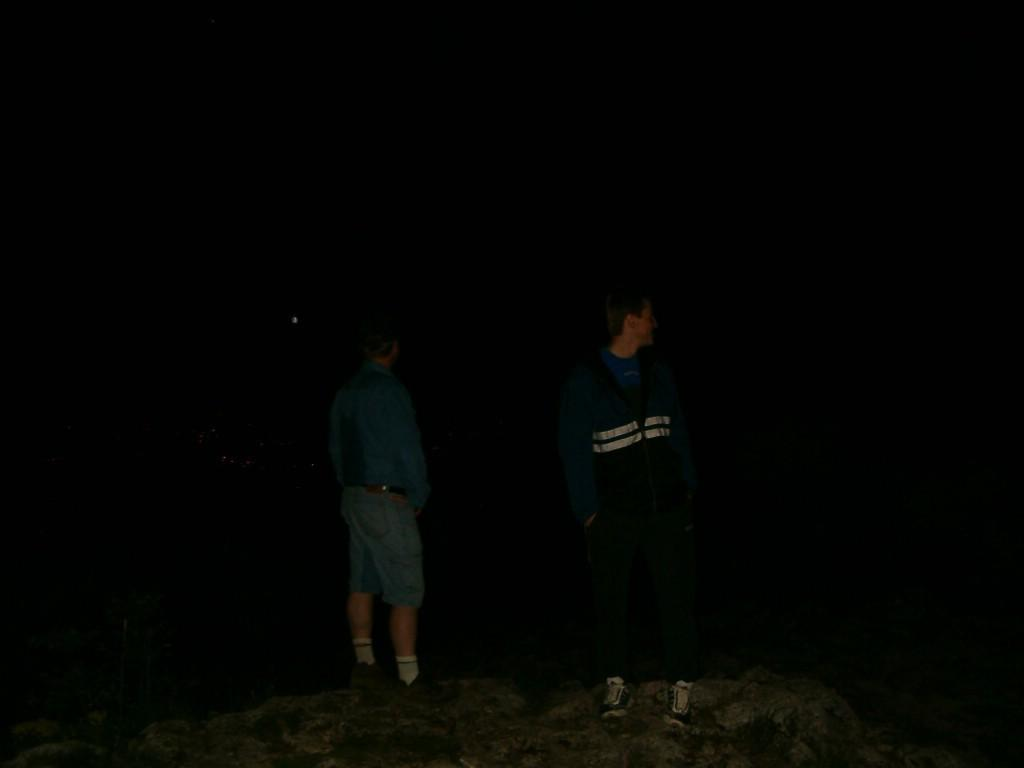How many people are in the image? There are two persons in the image. What are the two persons doing in the image? The two persons are standing on a rock. Can you describe the lighting in the image? The scene is dark. What type of rhythm can be heard from the toothbrush in the image? There is no toothbrush present in the image, and therefore no rhythm can be heard. 